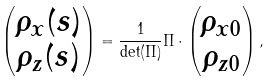Convert formula to latex. <formula><loc_0><loc_0><loc_500><loc_500>\begin{pmatrix} \rho _ { x } ( s ) \\ \rho _ { z } ( s ) \end{pmatrix} = \frac { 1 } { \det ( \Pi ) } \Pi \cdot \begin{pmatrix} \rho _ { x 0 } \\ \rho _ { z 0 } \end{pmatrix} ,</formula> 